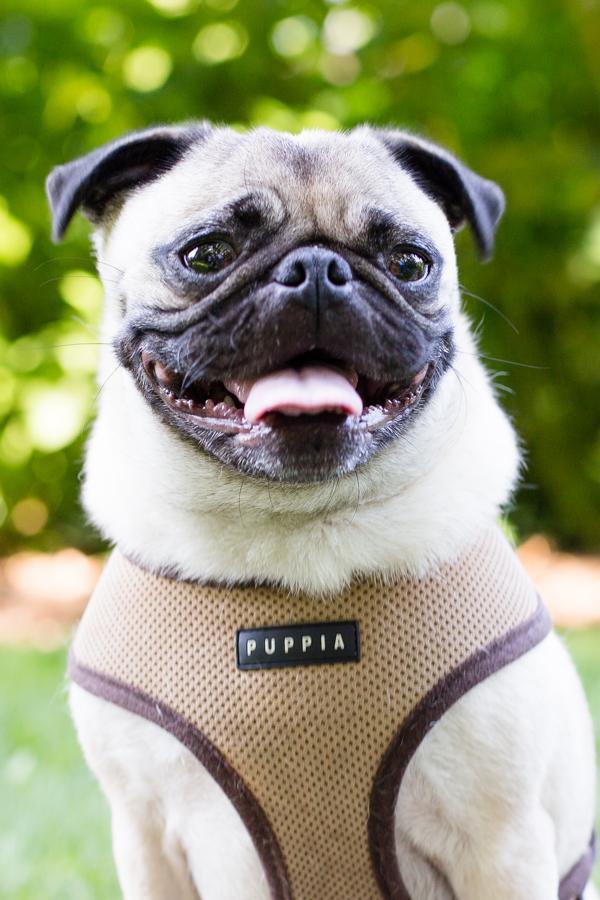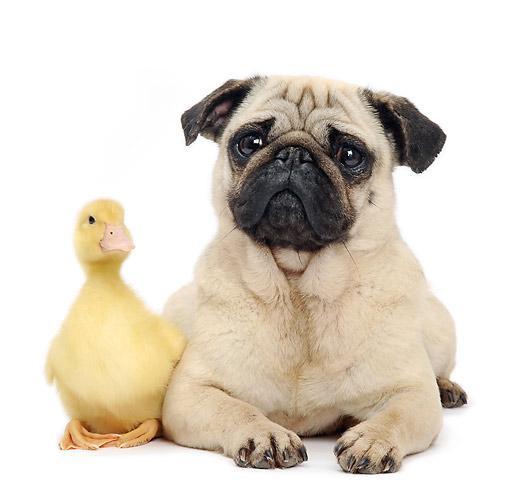The first image is the image on the left, the second image is the image on the right. Evaluate the accuracy of this statement regarding the images: "The dog in the right image is wearing a harness.". Is it true? Answer yes or no. No. The first image is the image on the left, the second image is the image on the right. Assess this claim about the two images: "There is one bird next to a dog.". Correct or not? Answer yes or no. Yes. 